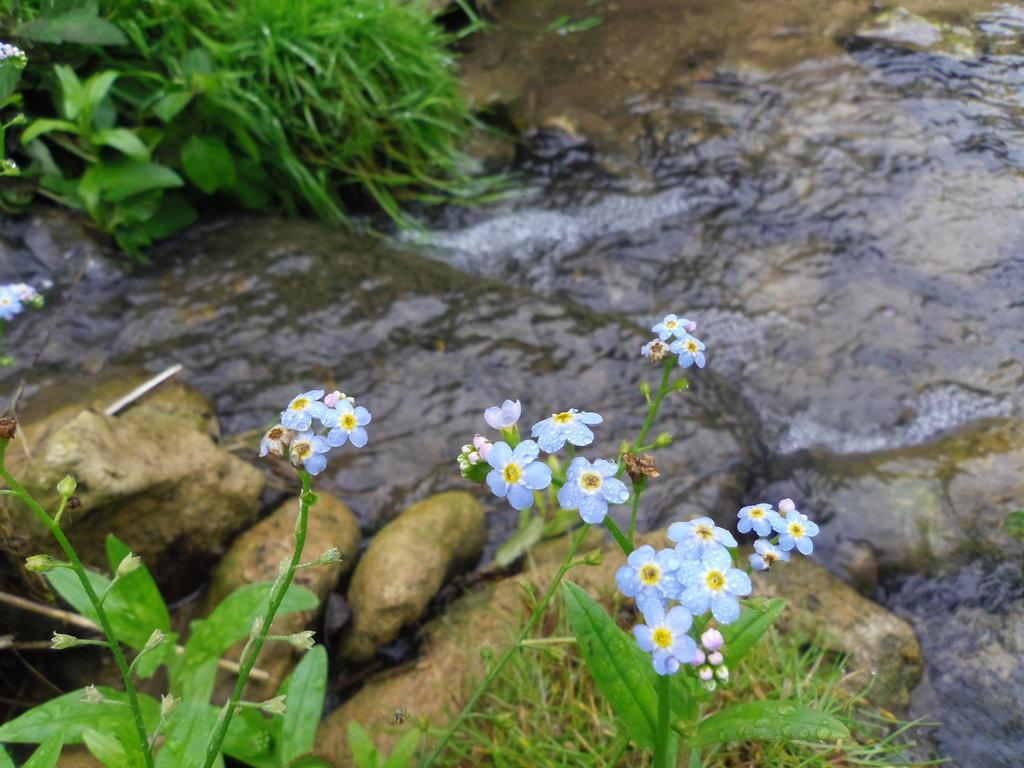What types of vegetation can be seen in the foreground of the picture? There are plants, flowers, and grass in the foreground of the picture. What else is present in the foreground of the picture? There are stones in the foreground of the picture. What is happening in the center of the picture? There is water flowing in the center of the picture. Are there any plants or grass visible at the top left of the picture? Yes, there are plants and grass at the top left of the picture. Can you tell me how many pickles are on the sofa in the image? There is no sofa or pickles present in the image. What color is the horse in the top right corner of the image? There is no horse present in the image. 